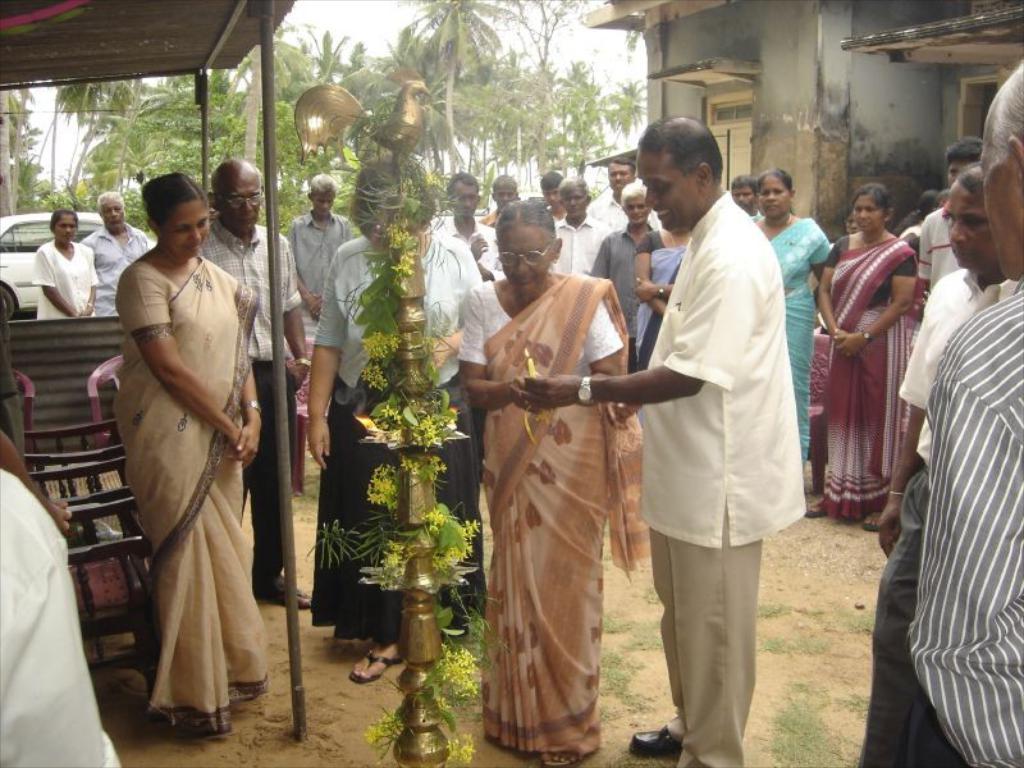Please provide a concise description of this image. There is a crowd. Person in the front is holding a candle with light. Also there is a light stand with decorations. There is a shed with poles. On the right side there is a building. In the background there are trees. Also there are chairs on the left side. 